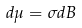Convert formula to latex. <formula><loc_0><loc_0><loc_500><loc_500>d \mu = \sigma d B</formula> 